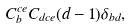Convert formula to latex. <formula><loc_0><loc_0><loc_500><loc_500>C _ { b } ^ { c e } C _ { d c e } ( d - 1 ) \delta _ { b d } ,</formula> 